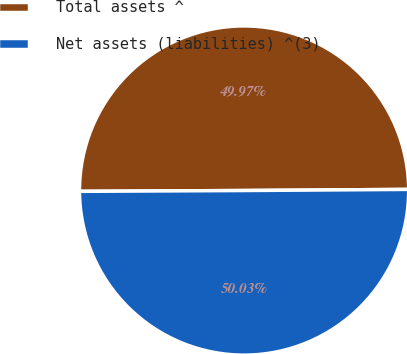Convert chart. <chart><loc_0><loc_0><loc_500><loc_500><pie_chart><fcel>Total assets ^<fcel>Net assets (liabilities) ^(3)<nl><fcel>49.97%<fcel>50.03%<nl></chart> 